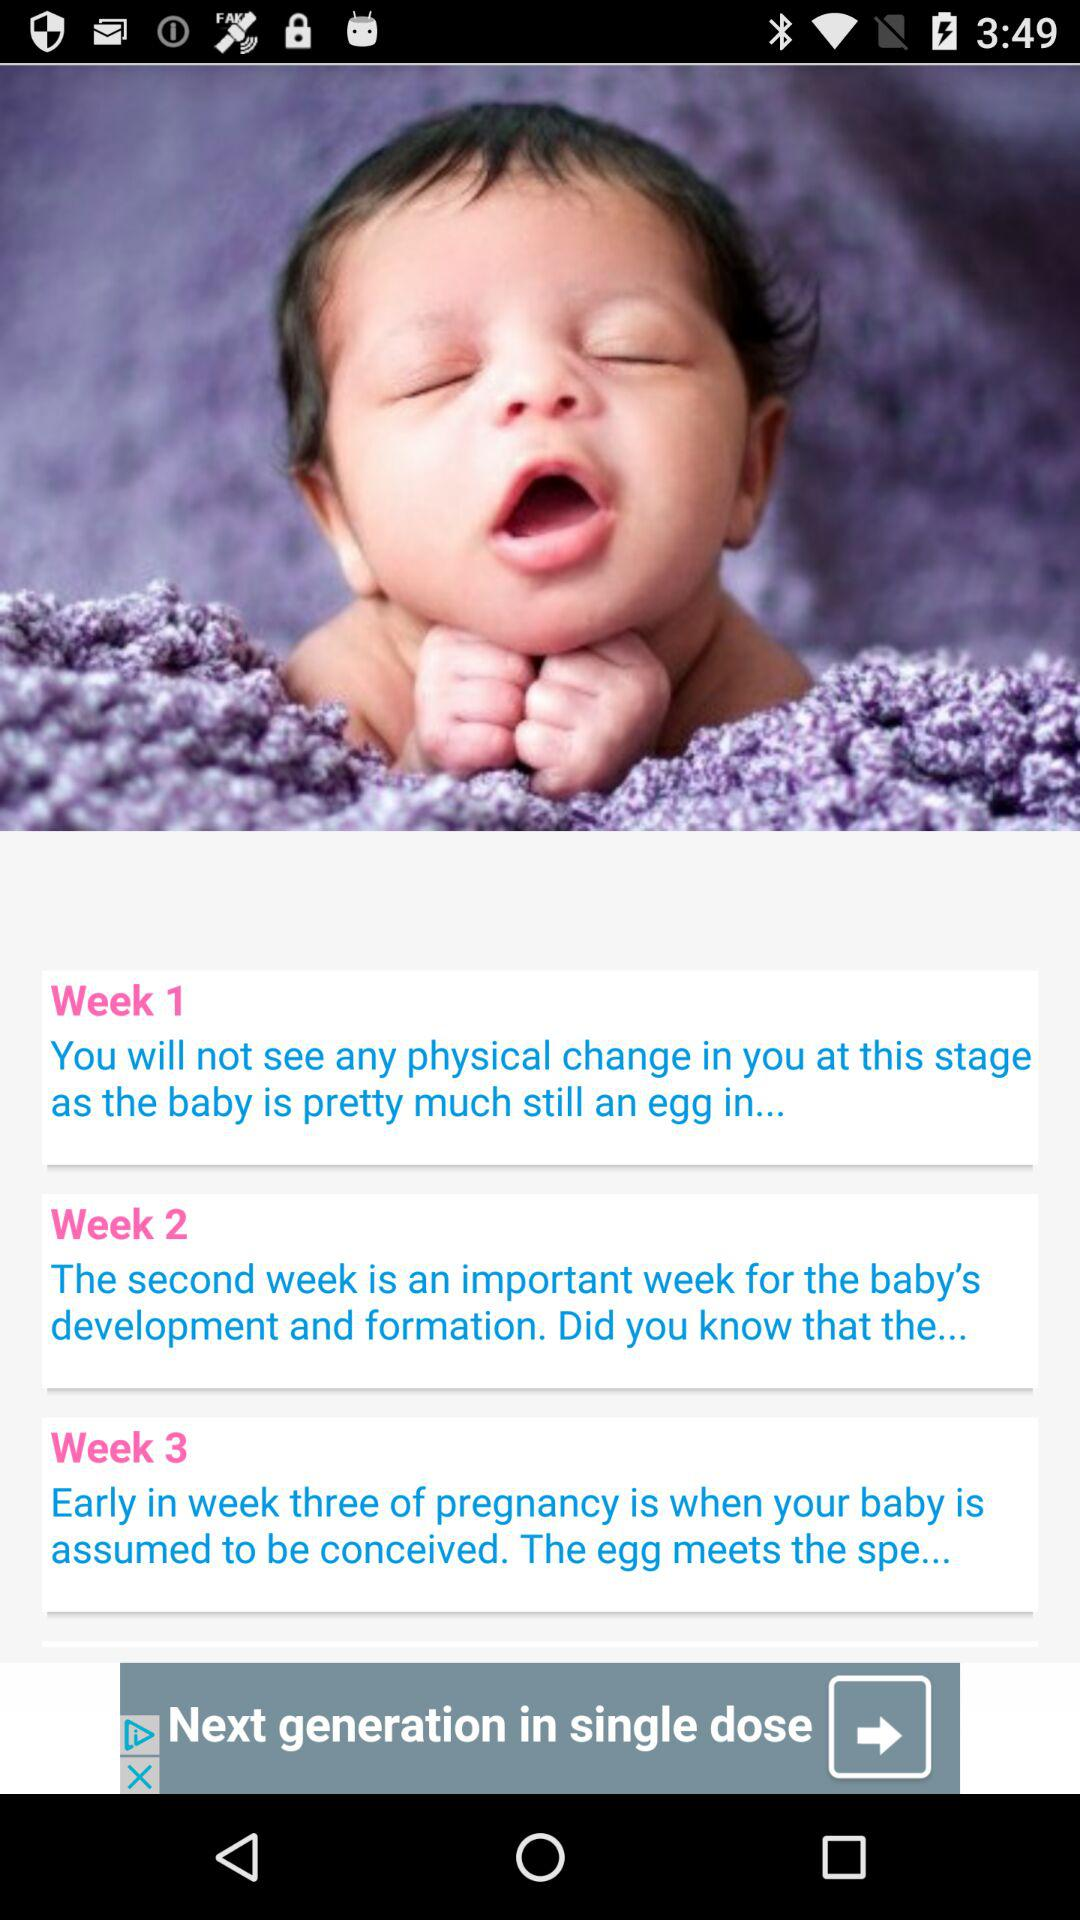How many weeks of pregnancy are covered in this app?
Answer the question using a single word or phrase. 3 